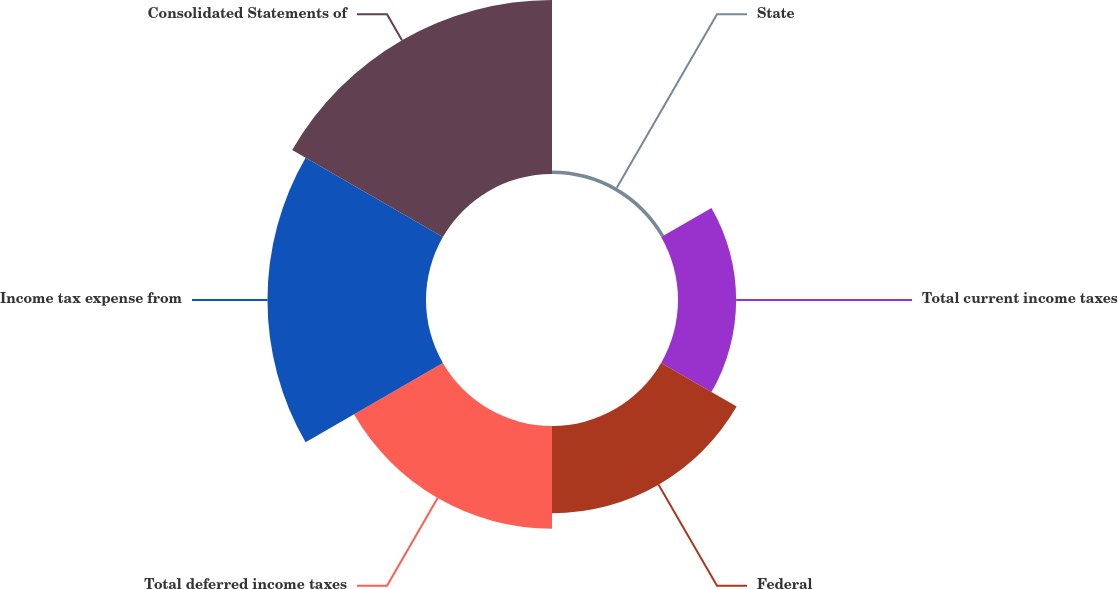Convert chart to OTSL. <chart><loc_0><loc_0><loc_500><loc_500><pie_chart><fcel>State<fcel>Total current income taxes<fcel>Federal<fcel>Total deferred income taxes<fcel>Income tax expense from<fcel>Consolidated Statements of<nl><fcel>0.61%<fcel>9.95%<fcel>14.93%<fcel>17.58%<fcel>27.14%<fcel>29.79%<nl></chart> 